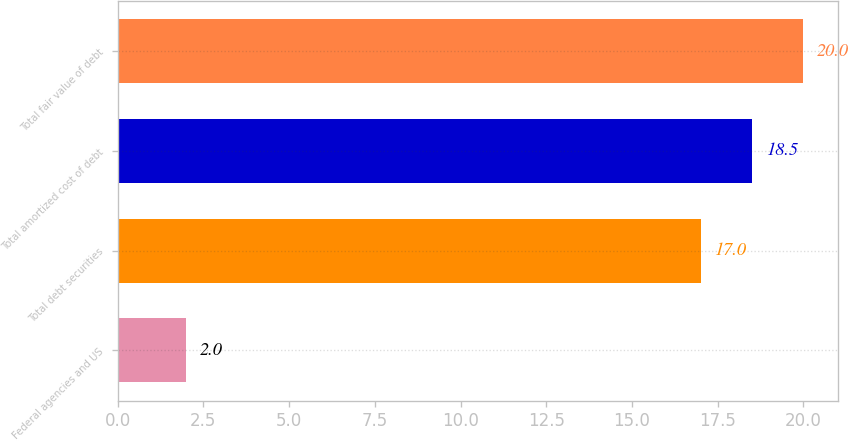Convert chart. <chart><loc_0><loc_0><loc_500><loc_500><bar_chart><fcel>Federal agencies and US<fcel>Total debt securities<fcel>Total amortized cost of debt<fcel>Total fair value of debt<nl><fcel>2<fcel>17<fcel>18.5<fcel>20<nl></chart> 